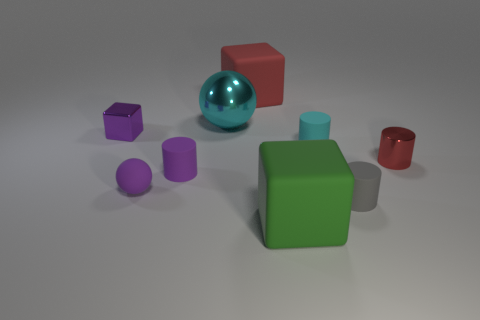Subtract all cyan cylinders. How many cylinders are left? 3 Subtract all green cubes. How many cubes are left? 2 Subtract 1 cyan cylinders. How many objects are left? 8 Subtract all spheres. How many objects are left? 7 Subtract 2 cubes. How many cubes are left? 1 Subtract all brown cylinders. Subtract all gray spheres. How many cylinders are left? 4 Subtract all small gray metal objects. Subtract all purple rubber cylinders. How many objects are left? 8 Add 3 large red matte blocks. How many large red matte blocks are left? 4 Add 1 large metal things. How many large metal things exist? 2 